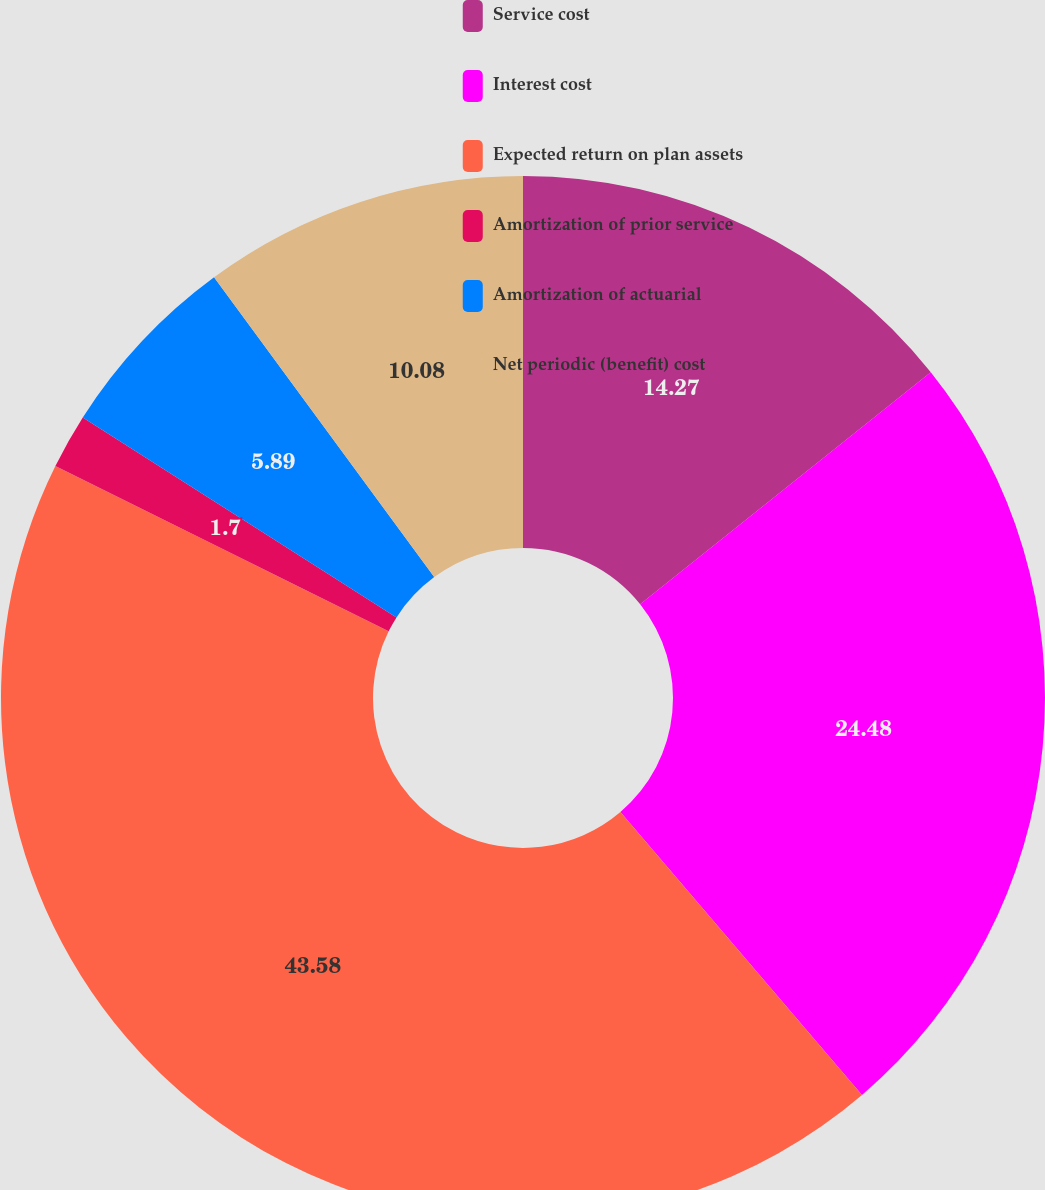<chart> <loc_0><loc_0><loc_500><loc_500><pie_chart><fcel>Service cost<fcel>Interest cost<fcel>Expected return on plan assets<fcel>Amortization of prior service<fcel>Amortization of actuarial<fcel>Net periodic (benefit) cost<nl><fcel>14.27%<fcel>24.48%<fcel>43.58%<fcel>1.7%<fcel>5.89%<fcel>10.08%<nl></chart> 